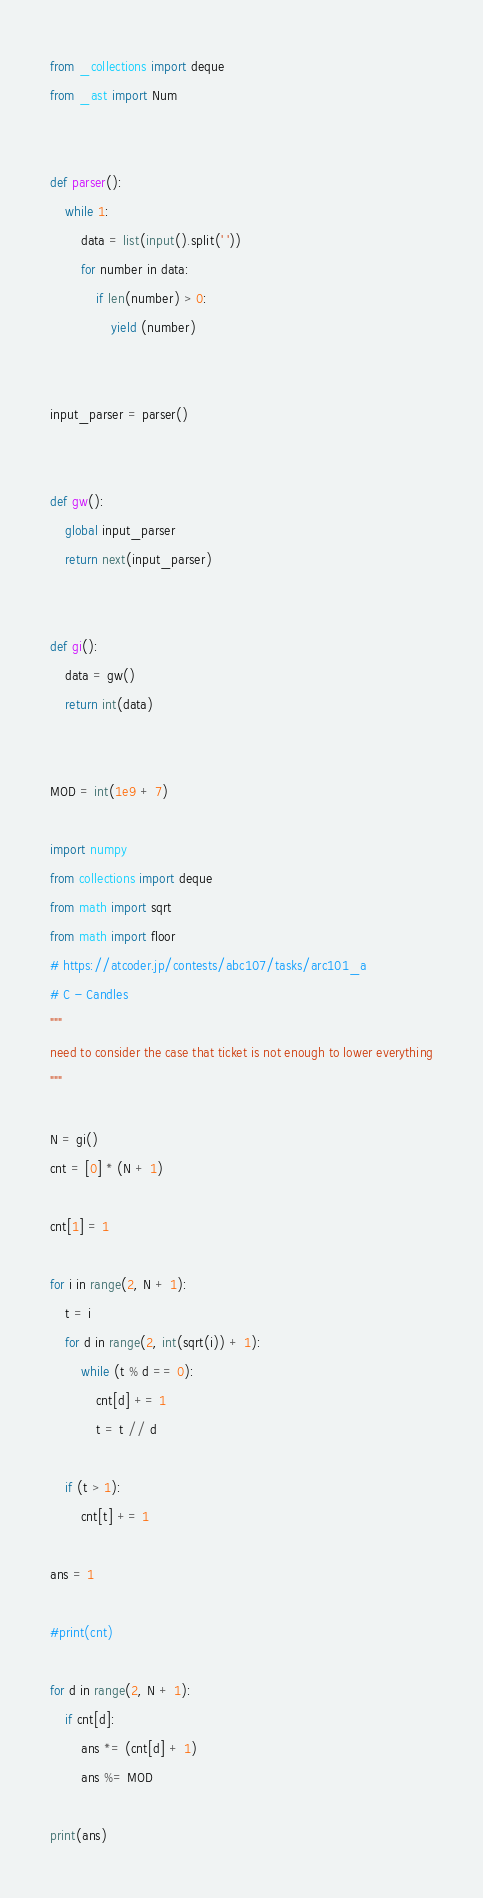Convert code to text. <code><loc_0><loc_0><loc_500><loc_500><_Python_>from _collections import deque
from _ast import Num


def parser():
    while 1:
        data = list(input().split(' '))
        for number in data:
            if len(number) > 0:
                yield (number)


input_parser = parser()


def gw():
    global input_parser
    return next(input_parser)


def gi():
    data = gw()
    return int(data)


MOD = int(1e9 + 7)

import numpy
from collections import deque
from math import sqrt
from math import floor
# https://atcoder.jp/contests/abc107/tasks/arc101_a
# C - Candles
"""
need to consider the case that ticket is not enough to lower everything
"""

N = gi()
cnt = [0] * (N + 1)

cnt[1] = 1

for i in range(2, N + 1):
    t = i
    for d in range(2, int(sqrt(i)) + 1):
        while (t % d == 0):
            cnt[d] += 1
            t = t // d

    if (t > 1):
        cnt[t] += 1

ans = 1

#print(cnt)

for d in range(2, N + 1):
    if cnt[d]:
        ans *= (cnt[d] + 1)
        ans %= MOD

print(ans)
</code> 